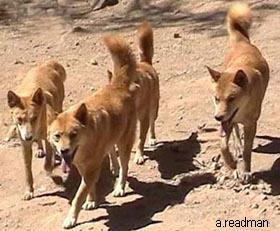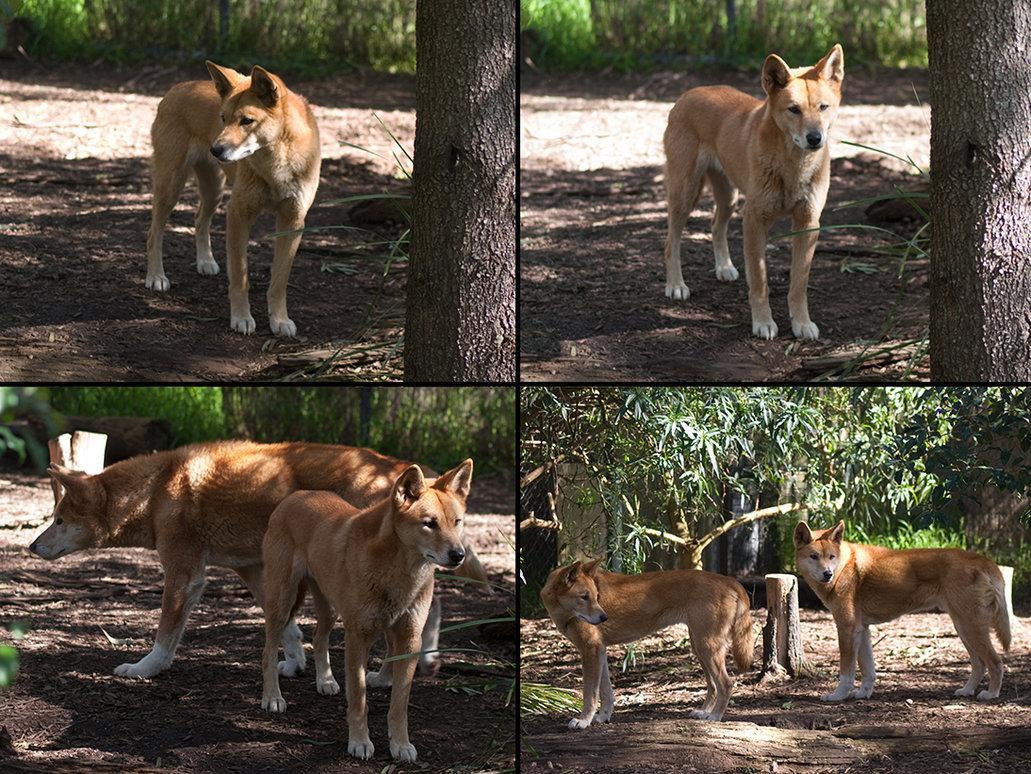The first image is the image on the left, the second image is the image on the right. Considering the images on both sides, is "An image shows an adult dog with at least one pup standing to reach it." valid? Answer yes or no. No. The first image is the image on the left, the second image is the image on the right. Analyze the images presented: Is the assertion "There is only one animal in the picture on the left." valid? Answer yes or no. No. 